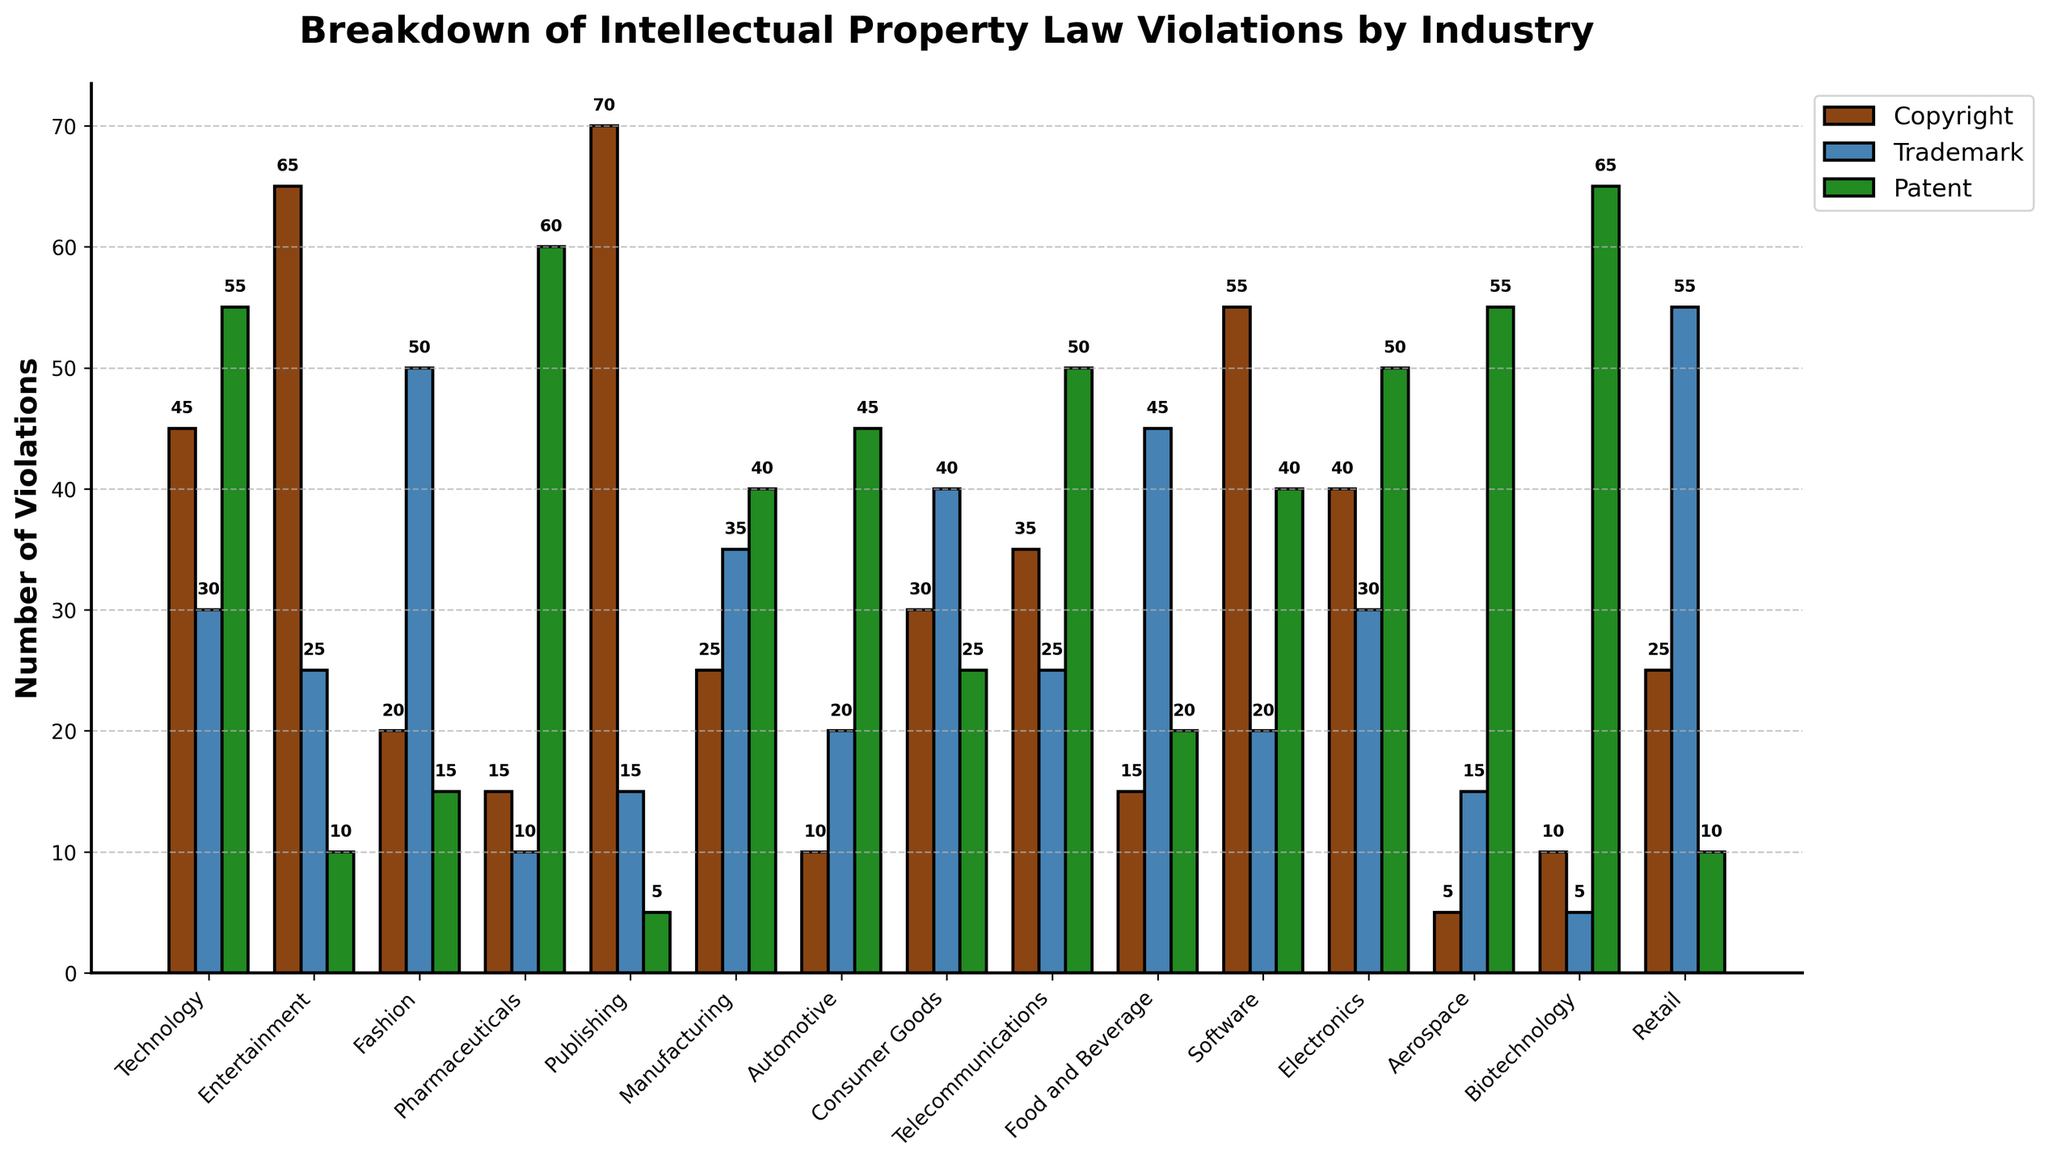**Question 1**: Which industry has the highest number of copyright violations? Explanation: Looking at the height of the brown bars for each industry, the industry with the highest bar represents the highest number of copyright violations. The Entertainment industry has the tallest brown bar at 65.
Answer: Entertainment **Question 2**: What is the difference in patent violations between the Biotechnology and Fashion industries? Explanation: The green bar for Biotechnology is at 65 while Fashion is at 15. The difference is calculated as 65 - 15.
Answer: 50 **Question 3**: Which industry has the lowest number of trademark violations? Explanation: By observing the blue bars for each industry, Biotechnology has the smallest bar with only 5 trademark violations.
Answer: Biotechnology **Question 4**: What is the total number of trademark violations for the Fashion and Retail industries combined? Explanation: The blue bar for Fashion is at 50, and for Retail, it is at 55. The sum is calculated as 50 + 55.
Answer: 105 **Question 5**: Which industry has more violations from patents, Aerospace or Automotive? Explanation: The green bar for Aerospace is at 55 and for Automotive is at 45. Comparing these values, Aerospace has more patent violations.
Answer: Aerospace **Question 6**: How many more copyright violations does the Publishing industry have compared to the Technology industry? Explanation: The brown bar for Publishing is at 70, and for Technology, it is at 45. Calculating the difference, 70 - 45.
Answer: 25 **Question 7**: Among all industries, which one has the greatest discrepancy between the number of copyright and patent violations? Explanation: Calculate the difference between the copyright and patent violations for each industry. The Publishing industry shows the maximum difference where copyright violations are 70 and patent violations are 5. The difference is 70 - 5.
Answer: Publishing **Question 8**: Considering only telecommunications and software industries, which one has a higher number of total violations (sum of copyright, trademark, and patent)? Explanation: Telecommunications has 35 copyright, 25 trademark, and 50 patent violations, summing up to 110. Software has 55 copyright, 20 trademark, and 40 patent violations, summing up to 115. Comparing 110 and 115, Software has higher total violations.
Answer: Software **Question 9**: What is the difference in total intellectual property violations between Consumer Goods and Food and Beverage industries? Explanation: Calculate the sum of violations for both industries and compare. Consumer Goods: 30 (copyright) + 40 (trademark) + 25 (patent) = 95. Food and Beverage: 15 (copyright) + 45 (trademark) + 20 (patent) = 80. Difference is 95 - 80.
Answer: 15 **Question 10**: What is the average number of patent violations across all industries? Explanation: Sum the patent violations of all industries and divide by the number of industries (15). Total patent violations: 55+10+15+60+5+40+45+25+50+20+40+50+55+65+10 = 545. The average is 545/15.
Answer: 36.33 